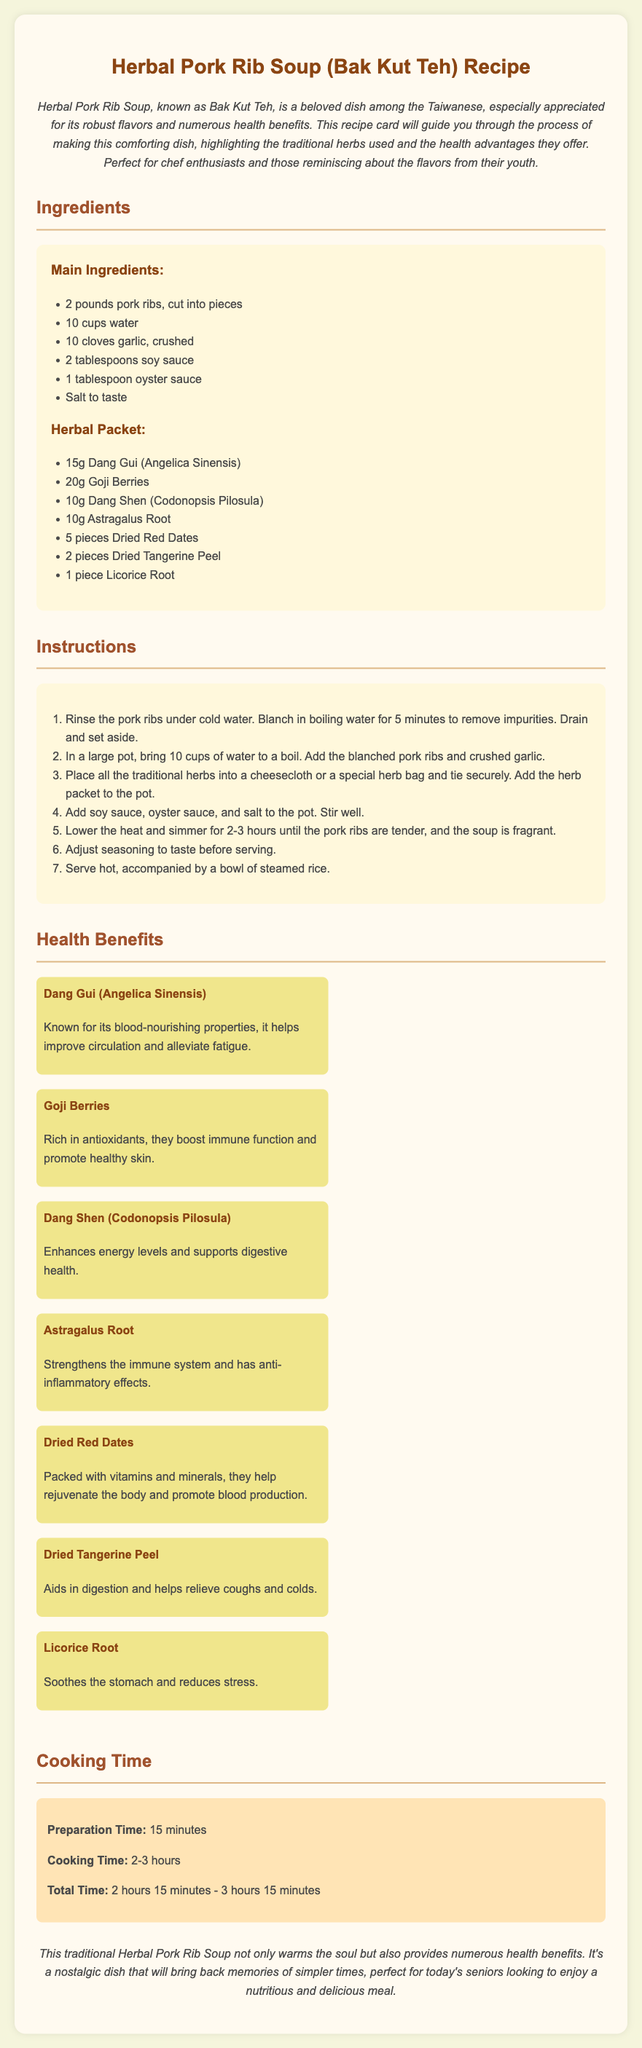What is the main dish name? The main dish featured in the document is Herbal Pork Rib Soup, commonly known as Bak Kut Teh.
Answer: Bak Kut Teh How many cups of water are needed? The recipe states that 10 cups of water are required for preparing the soup.
Answer: 10 cups What is the cooking time range? The document outlines that the cooking time for the soup is between 2 to 3 hours.
Answer: 2-3 hours How many cloves of garlic are used? It is mentioned that 10 cloves of garlic are crushed and used in the recipe.
Answer: 10 cloves What does Dang Gui help improve? The health benefit section states that Dang Gui helps improve circulation and alleviate fatigue.
Answer: Circulation and fatigue How many herbal ingredients are listed? There are 7 different traditional herbs mentioned in the herbal packet section of the recipe.
Answer: 7 What is the preparation time required? The document indicates that the preparation time for the soup is 15 minutes.
Answer: 15 minutes What does Licorice Root soothe? According to the health benefits, Licorice Root helps soothe the stomach.
Answer: Stomach What is a traditional accompaniment mentioned? The conclusion mentions that the Herbal Pork Rib Soup is served hot with steamed rice.
Answer: Steamed rice 